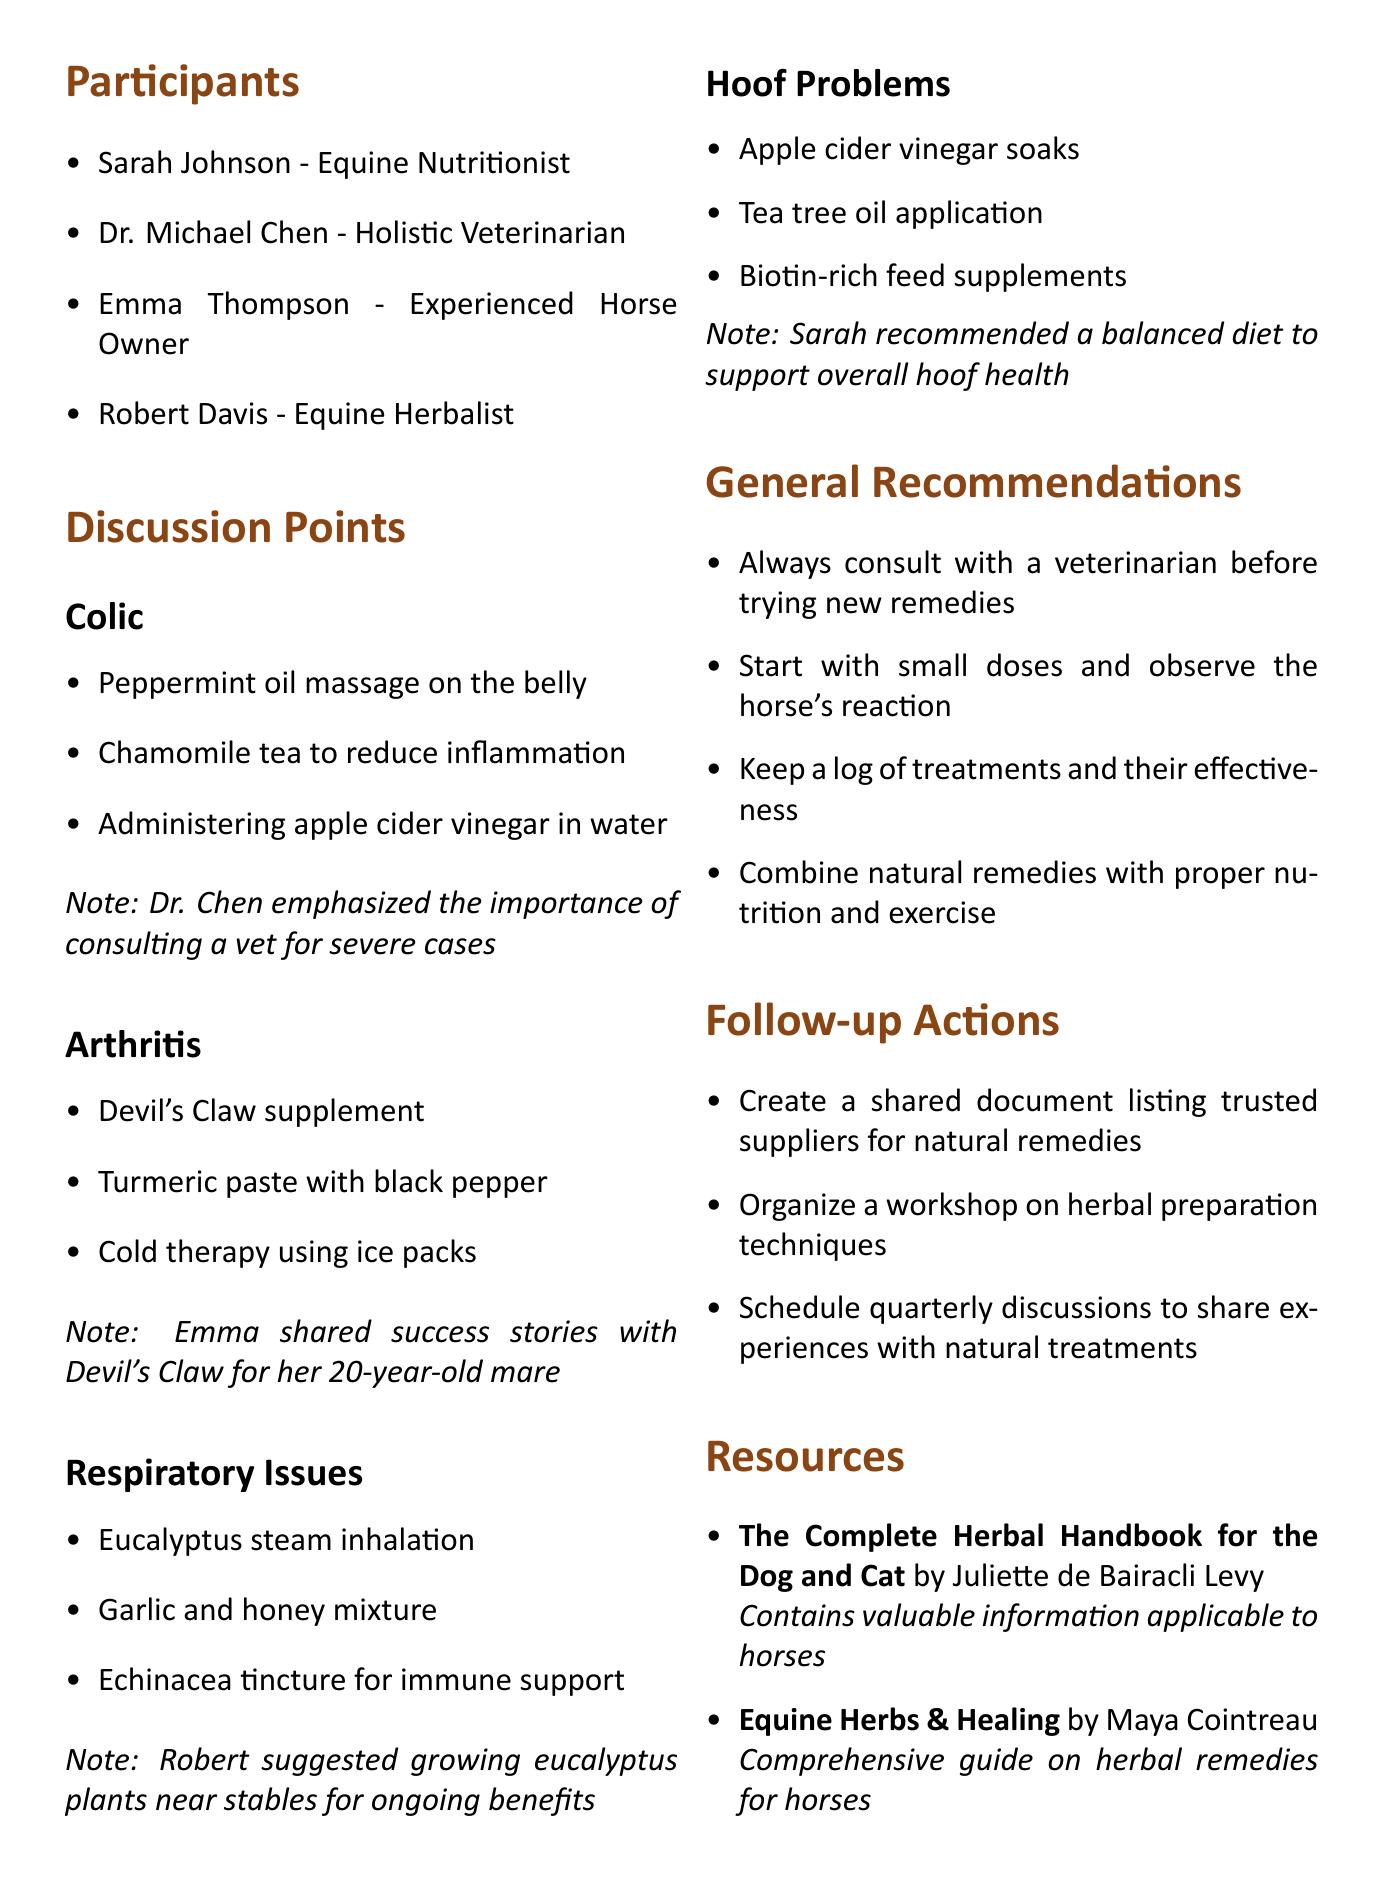What is the date of the discussion? The date is listed at the beginning of the document, which is May 15, 2023.
Answer: May 15, 2023 Who emphasized the importance of consulting a vet for severe cases of colic? The document states that Dr. Chen emphasized this importance during the discussion.
Answer: Dr. Michael Chen What natural remedy is recommended for arthritis? The discussion points mention several remedies, including Devil's Claw supplement which is specifically highlighted.
Answer: Devil's Claw supplement Which natural remedy is suggested for respiratory issues? The remedies for respiratory issues listed include eucalyptus steam inhalation, garlic and honey mixture, or echinacea tincture, with eucalyptus steam being the first mentioned.
Answer: Eucalyptus steam inhalation What are the follow-up actions agreed upon? The follow-up actions include creating a shared document for suppliers, organizing a workshop, and scheduling discussions. Each is an action to further the group's knowledge and sharing.
Answer: Create a shared document listing trusted suppliers for natural remedies What did Emma share regarding Devil’s Claw? Emma shared success stories with this remedy concerning her 20-year-old mare, indicating its effectiveness.
Answer: Success stories with Devil's Claw for her 20-year-old mare Who is the author of "Equine Herbs & Healing"? The author of the mentioned resource is Maya Cointreau, as detailed in the resources section.
Answer: Maya Cointreau What is one general recommendation from the discussion? The document lists several general recommendations, including the necessity of consulting a veterinarian before trying new remedies.
Answer: Always consult with a veterinarian before trying new remedies 